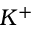Convert formula to latex. <formula><loc_0><loc_0><loc_500><loc_500>K ^ { + }</formula> 